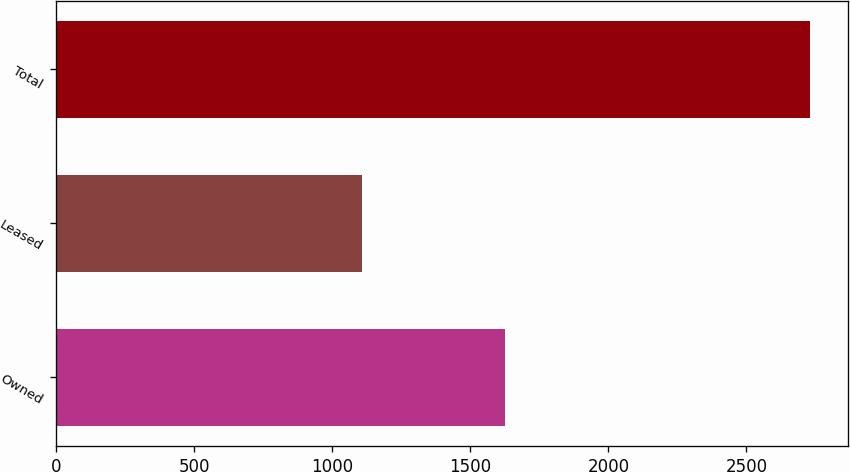<chart> <loc_0><loc_0><loc_500><loc_500><bar_chart><fcel>Owned<fcel>Leased<fcel>Total<nl><fcel>1624<fcel>1107<fcel>2731<nl></chart> 